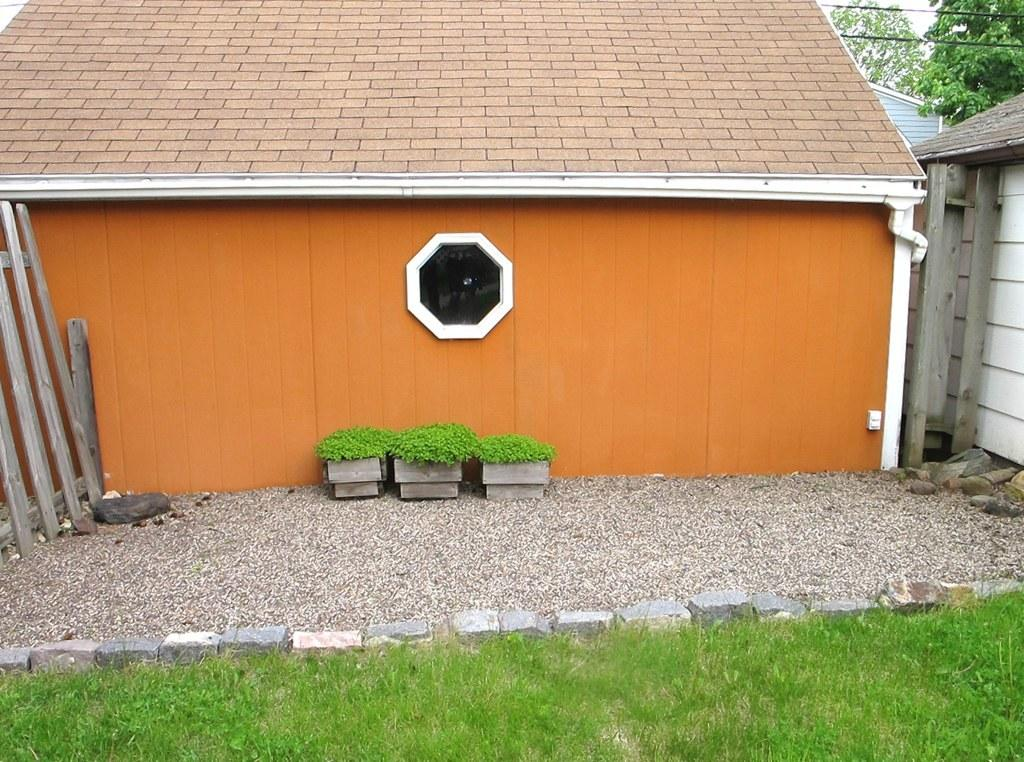What type of structures can be seen in the image? There are houses in the image. What type of vegetation is present in the image? There are plants, grass, and trees in the image. What materials can be seen in the image? There are wooden planks and stones in the image. What is visible in the background of the image? There are trees, wires, and the sky visible in the background of the image. What type of wire is being used by the uncle in the image? There is no uncle or wire present in the image. How is the string being used in the image? There is no string present in the image. 